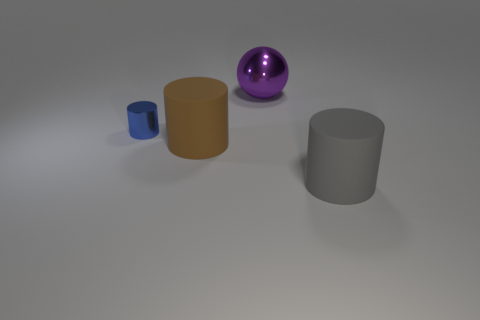Add 4 small metallic cylinders. How many objects exist? 8 Subtract all cylinders. How many objects are left? 1 Add 4 gray rubber things. How many gray rubber things exist? 5 Subtract 1 purple spheres. How many objects are left? 3 Subtract all big gray matte things. Subtract all balls. How many objects are left? 2 Add 2 gray rubber cylinders. How many gray rubber cylinders are left? 3 